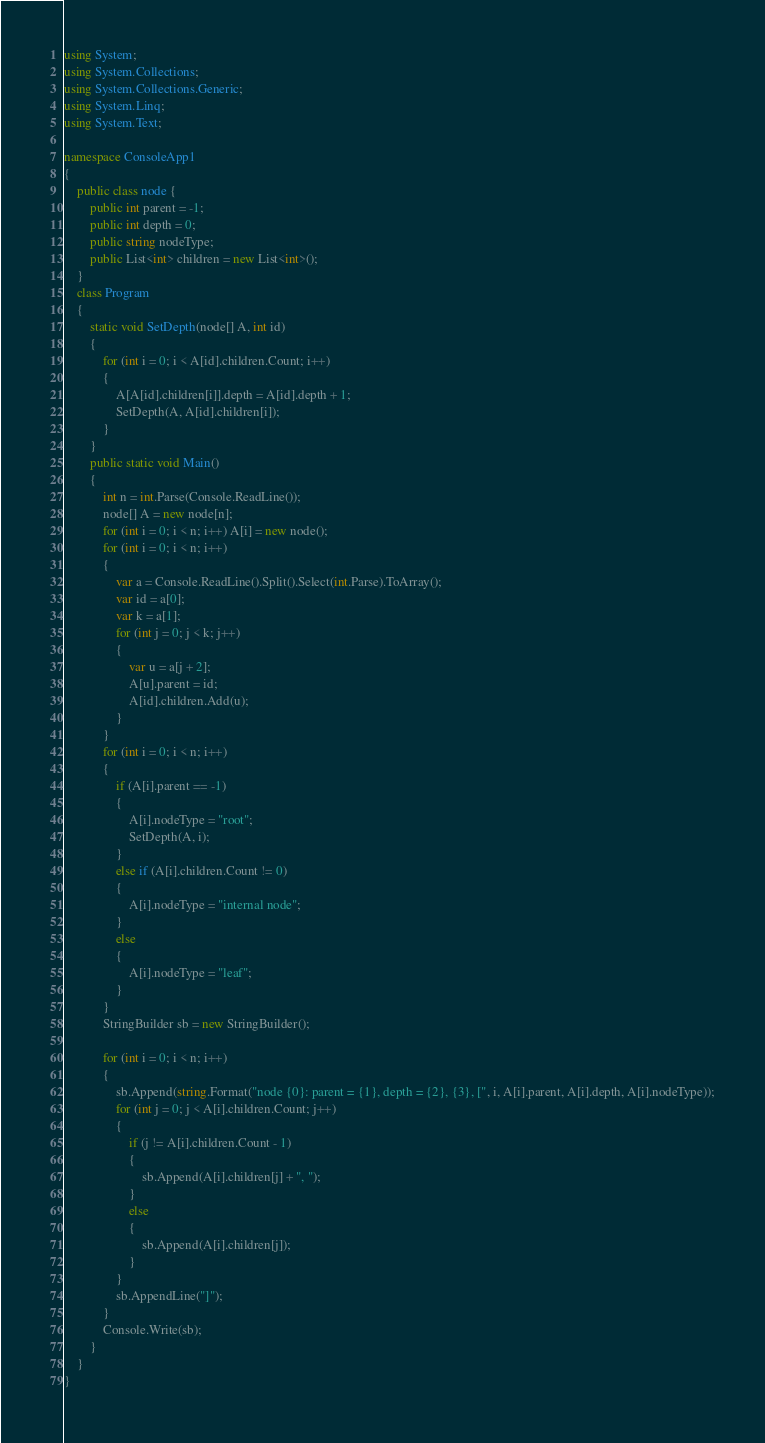Convert code to text. <code><loc_0><loc_0><loc_500><loc_500><_C#_>using System;
using System.Collections;
using System.Collections.Generic;
using System.Linq;
using System.Text;

namespace ConsoleApp1
{
    public class node {
        public int parent = -1;
        public int depth = 0;
        public string nodeType;
        public List<int> children = new List<int>();
    }
    class Program
    {
        static void SetDepth(node[] A, int id)
        {
            for (int i = 0; i < A[id].children.Count; i++)
            {
                A[A[id].children[i]].depth = A[id].depth + 1;
                SetDepth(A, A[id].children[i]);
            }
        }
        public static void Main()
        {
            int n = int.Parse(Console.ReadLine());
            node[] A = new node[n];
            for (int i = 0; i < n; i++) A[i] = new node();
            for (int i = 0; i < n; i++)
            {
                var a = Console.ReadLine().Split().Select(int.Parse).ToArray();
                var id = a[0];
                var k = a[1];
                for (int j = 0; j < k; j++)
                {
                    var u = a[j + 2];
                    A[u].parent = id;
                    A[id].children.Add(u);
                }
            }
            for (int i = 0; i < n; i++)
            {
                if (A[i].parent == -1)
                {
                    A[i].nodeType = "root";
                    SetDepth(A, i);
                }
                else if (A[i].children.Count != 0)
                {
                    A[i].nodeType = "internal node";
                }
                else
                {
                    A[i].nodeType = "leaf";
                }
            }
            StringBuilder sb = new StringBuilder();

            for (int i = 0; i < n; i++)
            {
                sb.Append(string.Format("node {0}: parent = {1}, depth = {2}, {3}, [", i, A[i].parent, A[i].depth, A[i].nodeType));
                for (int j = 0; j < A[i].children.Count; j++)
                {
                    if (j != A[i].children.Count - 1)
                    {
                        sb.Append(A[i].children[j] + ", ");
                    }
                    else
                    {
                        sb.Append(A[i].children[j]);
                    }
                }
                sb.AppendLine("]");
            }
            Console.Write(sb);
        }
    }
}

</code> 